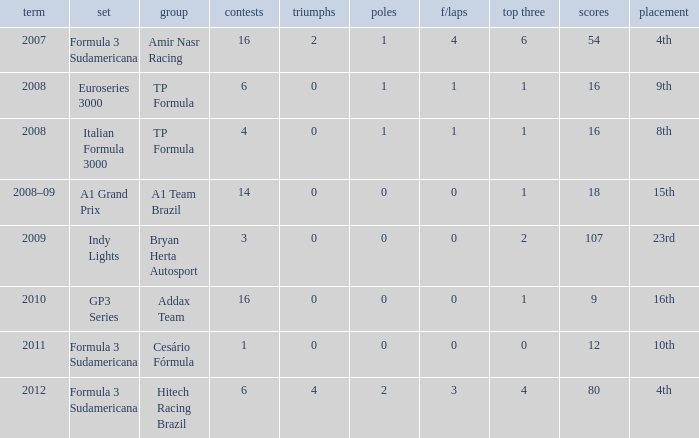What team did he compete for in the GP3 series? Addax Team. 